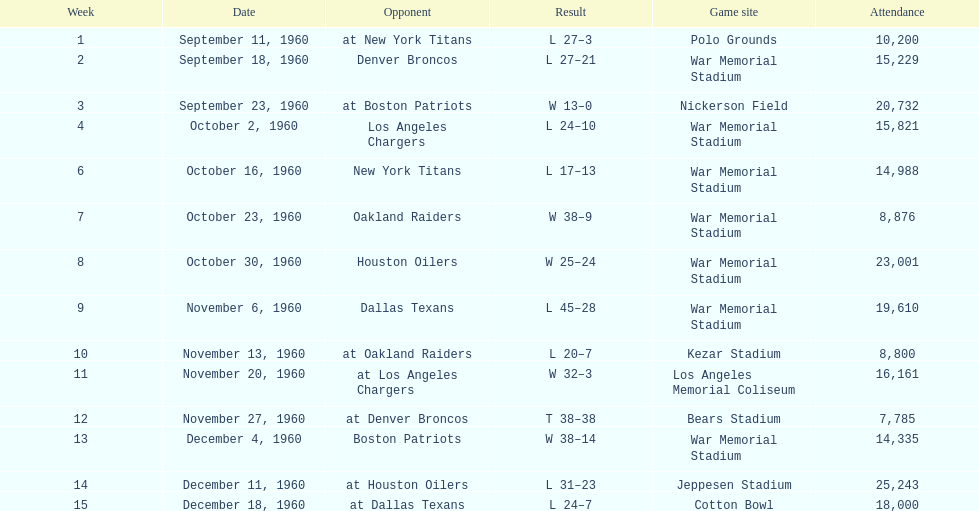Who was the only opponent they played which resulted in a tie game? Denver Broncos. 